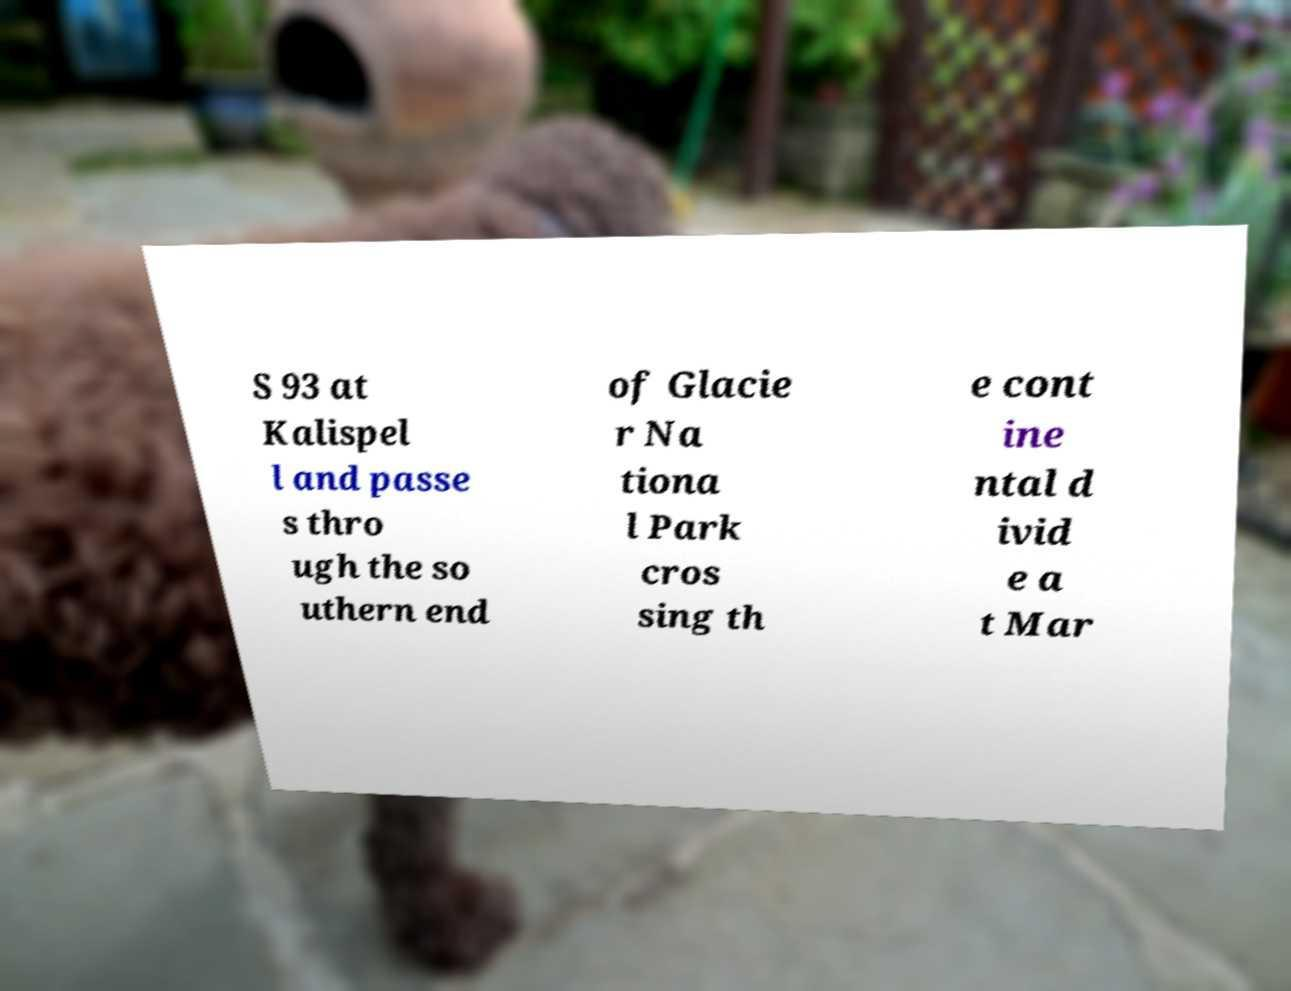Please identify and transcribe the text found in this image. S 93 at Kalispel l and passe s thro ugh the so uthern end of Glacie r Na tiona l Park cros sing th e cont ine ntal d ivid e a t Mar 